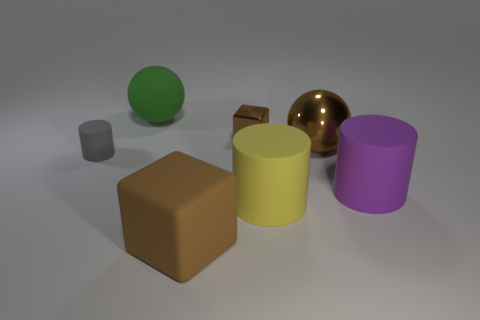What is the material of the large cube that is the same color as the large shiny ball?
Keep it short and to the point. Rubber. There is another yellow matte object that is the same shape as the tiny matte thing; what is its size?
Your response must be concise. Large. There is a tiny object that is on the left side of the tiny metallic thing; does it have the same color as the big shiny sphere?
Your answer should be very brief. No. Are there fewer shiny cubes than large purple cubes?
Make the answer very short. No. How many other things are the same color as the small matte object?
Make the answer very short. 0. Is the material of the big brown object to the right of the brown rubber thing the same as the green thing?
Give a very brief answer. No. What is the material of the tiny thing right of the large green rubber thing?
Keep it short and to the point. Metal. There is a object that is behind the brown cube that is behind the small rubber object; what is its size?
Your response must be concise. Large. Is there a small brown block that has the same material as the yellow cylinder?
Offer a very short reply. No. What shape is the tiny object behind the large ball that is right of the big brown matte thing that is to the left of the big yellow cylinder?
Give a very brief answer. Cube. 